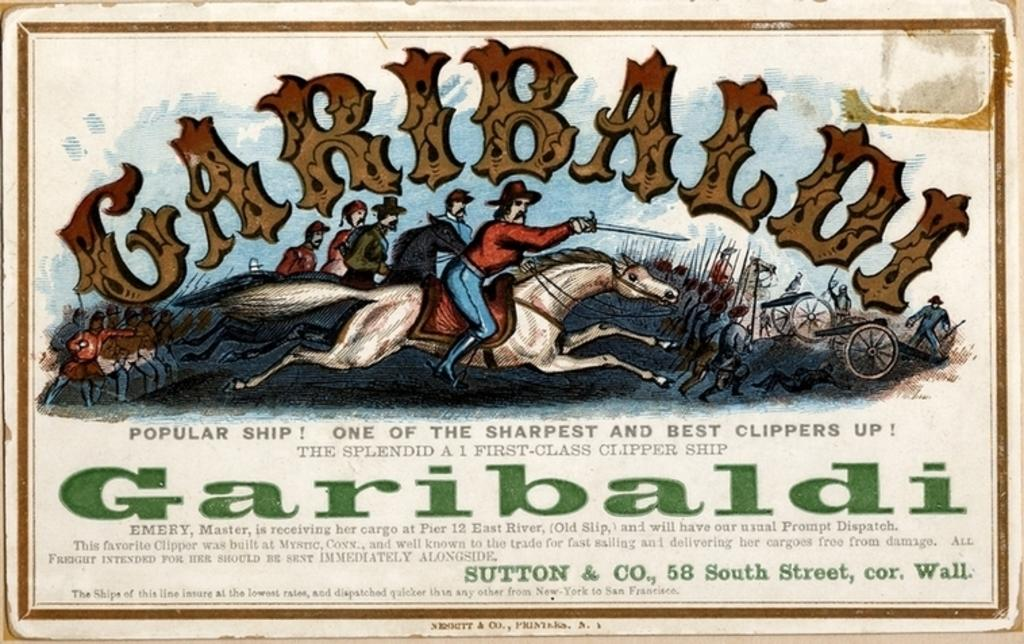What is being depicted in the image? There is a depiction of people and a horse in the image. What else can be seen in the image besides the people and the horse? There is text written in the image. Is there a vessel carrying rain in the image? There is no vessel carrying rain in the image. Can you see a grandfather in the image? There is no grandfather depicted in the image. 